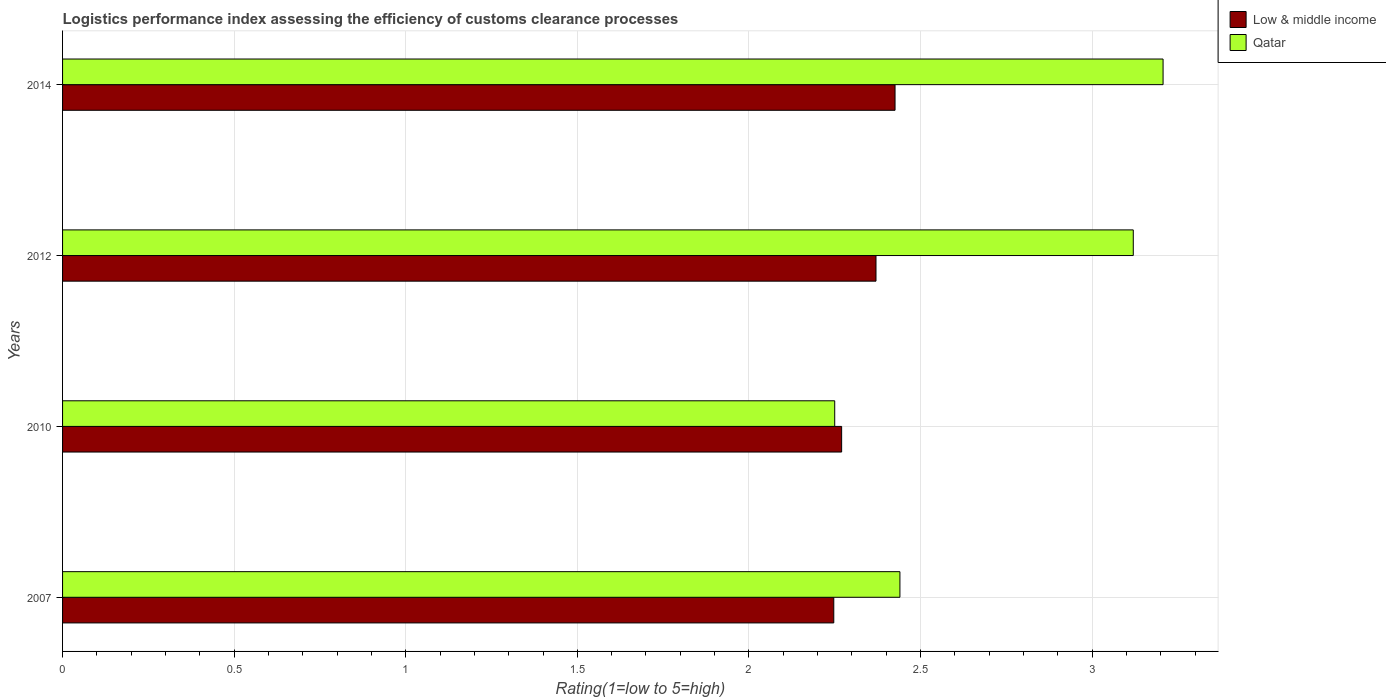Are the number of bars per tick equal to the number of legend labels?
Provide a succinct answer. Yes. Are the number of bars on each tick of the Y-axis equal?
Ensure brevity in your answer.  Yes. What is the label of the 4th group of bars from the top?
Make the answer very short. 2007. What is the Logistic performance index in Qatar in 2010?
Your response must be concise. 2.25. Across all years, what is the maximum Logistic performance index in Low & middle income?
Provide a succinct answer. 2.43. Across all years, what is the minimum Logistic performance index in Qatar?
Give a very brief answer. 2.25. In which year was the Logistic performance index in Low & middle income maximum?
Provide a short and direct response. 2014. In which year was the Logistic performance index in Qatar minimum?
Your answer should be compact. 2010. What is the total Logistic performance index in Low & middle income in the graph?
Make the answer very short. 9.31. What is the difference between the Logistic performance index in Qatar in 2010 and that in 2012?
Ensure brevity in your answer.  -0.87. What is the difference between the Logistic performance index in Qatar in 2007 and the Logistic performance index in Low & middle income in 2012?
Your answer should be very brief. 0.07. What is the average Logistic performance index in Low & middle income per year?
Give a very brief answer. 2.33. In the year 2007, what is the difference between the Logistic performance index in Low & middle income and Logistic performance index in Qatar?
Your answer should be very brief. -0.19. In how many years, is the Logistic performance index in Qatar greater than 2.8 ?
Your response must be concise. 2. What is the ratio of the Logistic performance index in Low & middle income in 2012 to that in 2014?
Ensure brevity in your answer.  0.98. Is the Logistic performance index in Qatar in 2007 less than that in 2010?
Your response must be concise. No. Is the difference between the Logistic performance index in Low & middle income in 2007 and 2010 greater than the difference between the Logistic performance index in Qatar in 2007 and 2010?
Give a very brief answer. No. What is the difference between the highest and the second highest Logistic performance index in Qatar?
Give a very brief answer. 0.09. What is the difference between the highest and the lowest Logistic performance index in Low & middle income?
Your response must be concise. 0.18. In how many years, is the Logistic performance index in Low & middle income greater than the average Logistic performance index in Low & middle income taken over all years?
Your answer should be very brief. 2. Is the sum of the Logistic performance index in Low & middle income in 2007 and 2012 greater than the maximum Logistic performance index in Qatar across all years?
Offer a very short reply. Yes. What does the 2nd bar from the top in 2014 represents?
Offer a terse response. Low & middle income. What does the 2nd bar from the bottom in 2007 represents?
Keep it short and to the point. Qatar. Are all the bars in the graph horizontal?
Your answer should be compact. Yes. What is the difference between two consecutive major ticks on the X-axis?
Your response must be concise. 0.5. How many legend labels are there?
Ensure brevity in your answer.  2. How are the legend labels stacked?
Your answer should be compact. Vertical. What is the title of the graph?
Make the answer very short. Logistics performance index assessing the efficiency of customs clearance processes. What is the label or title of the X-axis?
Your answer should be compact. Rating(1=low to 5=high). What is the Rating(1=low to 5=high) in Low & middle income in 2007?
Give a very brief answer. 2.25. What is the Rating(1=low to 5=high) in Qatar in 2007?
Make the answer very short. 2.44. What is the Rating(1=low to 5=high) in Low & middle income in 2010?
Offer a terse response. 2.27. What is the Rating(1=low to 5=high) of Qatar in 2010?
Provide a succinct answer. 2.25. What is the Rating(1=low to 5=high) of Low & middle income in 2012?
Make the answer very short. 2.37. What is the Rating(1=low to 5=high) in Qatar in 2012?
Keep it short and to the point. 3.12. What is the Rating(1=low to 5=high) in Low & middle income in 2014?
Your answer should be very brief. 2.43. What is the Rating(1=low to 5=high) of Qatar in 2014?
Provide a short and direct response. 3.21. Across all years, what is the maximum Rating(1=low to 5=high) of Low & middle income?
Ensure brevity in your answer.  2.43. Across all years, what is the maximum Rating(1=low to 5=high) of Qatar?
Your answer should be very brief. 3.21. Across all years, what is the minimum Rating(1=low to 5=high) in Low & middle income?
Keep it short and to the point. 2.25. Across all years, what is the minimum Rating(1=low to 5=high) in Qatar?
Your answer should be very brief. 2.25. What is the total Rating(1=low to 5=high) in Low & middle income in the graph?
Offer a terse response. 9.31. What is the total Rating(1=low to 5=high) in Qatar in the graph?
Your answer should be compact. 11.02. What is the difference between the Rating(1=low to 5=high) in Low & middle income in 2007 and that in 2010?
Ensure brevity in your answer.  -0.02. What is the difference between the Rating(1=low to 5=high) in Qatar in 2007 and that in 2010?
Your answer should be compact. 0.19. What is the difference between the Rating(1=low to 5=high) of Low & middle income in 2007 and that in 2012?
Your response must be concise. -0.12. What is the difference between the Rating(1=low to 5=high) of Qatar in 2007 and that in 2012?
Your answer should be very brief. -0.68. What is the difference between the Rating(1=low to 5=high) in Low & middle income in 2007 and that in 2014?
Ensure brevity in your answer.  -0.18. What is the difference between the Rating(1=low to 5=high) of Qatar in 2007 and that in 2014?
Provide a succinct answer. -0.77. What is the difference between the Rating(1=low to 5=high) in Low & middle income in 2010 and that in 2012?
Give a very brief answer. -0.1. What is the difference between the Rating(1=low to 5=high) of Qatar in 2010 and that in 2012?
Make the answer very short. -0.87. What is the difference between the Rating(1=low to 5=high) in Low & middle income in 2010 and that in 2014?
Your response must be concise. -0.16. What is the difference between the Rating(1=low to 5=high) of Qatar in 2010 and that in 2014?
Offer a very short reply. -0.96. What is the difference between the Rating(1=low to 5=high) of Low & middle income in 2012 and that in 2014?
Make the answer very short. -0.06. What is the difference between the Rating(1=low to 5=high) in Qatar in 2012 and that in 2014?
Give a very brief answer. -0.09. What is the difference between the Rating(1=low to 5=high) of Low & middle income in 2007 and the Rating(1=low to 5=high) of Qatar in 2010?
Make the answer very short. -0. What is the difference between the Rating(1=low to 5=high) in Low & middle income in 2007 and the Rating(1=low to 5=high) in Qatar in 2012?
Provide a short and direct response. -0.87. What is the difference between the Rating(1=low to 5=high) in Low & middle income in 2007 and the Rating(1=low to 5=high) in Qatar in 2014?
Keep it short and to the point. -0.96. What is the difference between the Rating(1=low to 5=high) of Low & middle income in 2010 and the Rating(1=low to 5=high) of Qatar in 2012?
Keep it short and to the point. -0.85. What is the difference between the Rating(1=low to 5=high) of Low & middle income in 2010 and the Rating(1=low to 5=high) of Qatar in 2014?
Your answer should be very brief. -0.94. What is the difference between the Rating(1=low to 5=high) in Low & middle income in 2012 and the Rating(1=low to 5=high) in Qatar in 2014?
Your response must be concise. -0.84. What is the average Rating(1=low to 5=high) in Low & middle income per year?
Offer a terse response. 2.33. What is the average Rating(1=low to 5=high) of Qatar per year?
Your answer should be very brief. 2.75. In the year 2007, what is the difference between the Rating(1=low to 5=high) in Low & middle income and Rating(1=low to 5=high) in Qatar?
Your answer should be compact. -0.19. In the year 2010, what is the difference between the Rating(1=low to 5=high) in Low & middle income and Rating(1=low to 5=high) in Qatar?
Give a very brief answer. 0.02. In the year 2012, what is the difference between the Rating(1=low to 5=high) in Low & middle income and Rating(1=low to 5=high) in Qatar?
Offer a very short reply. -0.75. In the year 2014, what is the difference between the Rating(1=low to 5=high) of Low & middle income and Rating(1=low to 5=high) of Qatar?
Give a very brief answer. -0.78. What is the ratio of the Rating(1=low to 5=high) in Low & middle income in 2007 to that in 2010?
Give a very brief answer. 0.99. What is the ratio of the Rating(1=low to 5=high) of Qatar in 2007 to that in 2010?
Give a very brief answer. 1.08. What is the ratio of the Rating(1=low to 5=high) in Low & middle income in 2007 to that in 2012?
Your answer should be very brief. 0.95. What is the ratio of the Rating(1=low to 5=high) in Qatar in 2007 to that in 2012?
Offer a terse response. 0.78. What is the ratio of the Rating(1=low to 5=high) in Low & middle income in 2007 to that in 2014?
Offer a terse response. 0.93. What is the ratio of the Rating(1=low to 5=high) of Qatar in 2007 to that in 2014?
Provide a succinct answer. 0.76. What is the ratio of the Rating(1=low to 5=high) of Low & middle income in 2010 to that in 2012?
Offer a very short reply. 0.96. What is the ratio of the Rating(1=low to 5=high) of Qatar in 2010 to that in 2012?
Your answer should be very brief. 0.72. What is the ratio of the Rating(1=low to 5=high) in Low & middle income in 2010 to that in 2014?
Offer a very short reply. 0.94. What is the ratio of the Rating(1=low to 5=high) in Qatar in 2010 to that in 2014?
Provide a short and direct response. 0.7. What is the ratio of the Rating(1=low to 5=high) of Low & middle income in 2012 to that in 2014?
Keep it short and to the point. 0.98. What is the ratio of the Rating(1=low to 5=high) of Qatar in 2012 to that in 2014?
Make the answer very short. 0.97. What is the difference between the highest and the second highest Rating(1=low to 5=high) of Low & middle income?
Offer a very short reply. 0.06. What is the difference between the highest and the second highest Rating(1=low to 5=high) of Qatar?
Provide a succinct answer. 0.09. What is the difference between the highest and the lowest Rating(1=low to 5=high) in Low & middle income?
Keep it short and to the point. 0.18. What is the difference between the highest and the lowest Rating(1=low to 5=high) of Qatar?
Offer a terse response. 0.96. 